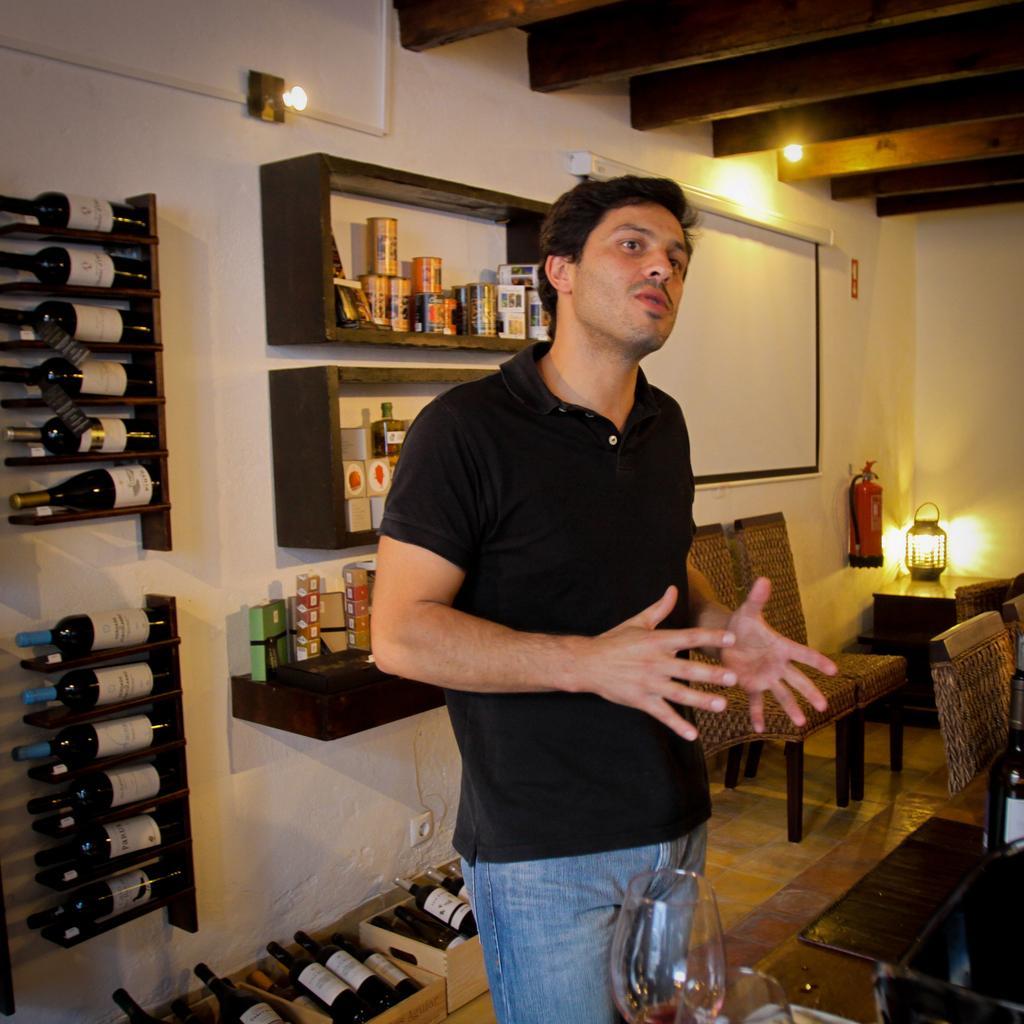Can you describe this image briefly? In this picture we can see a man who is standing on the floor. This is table. On the table there is a glass. These are the chairs. On the background we can see some bottles. And this is rack and there are lights. 